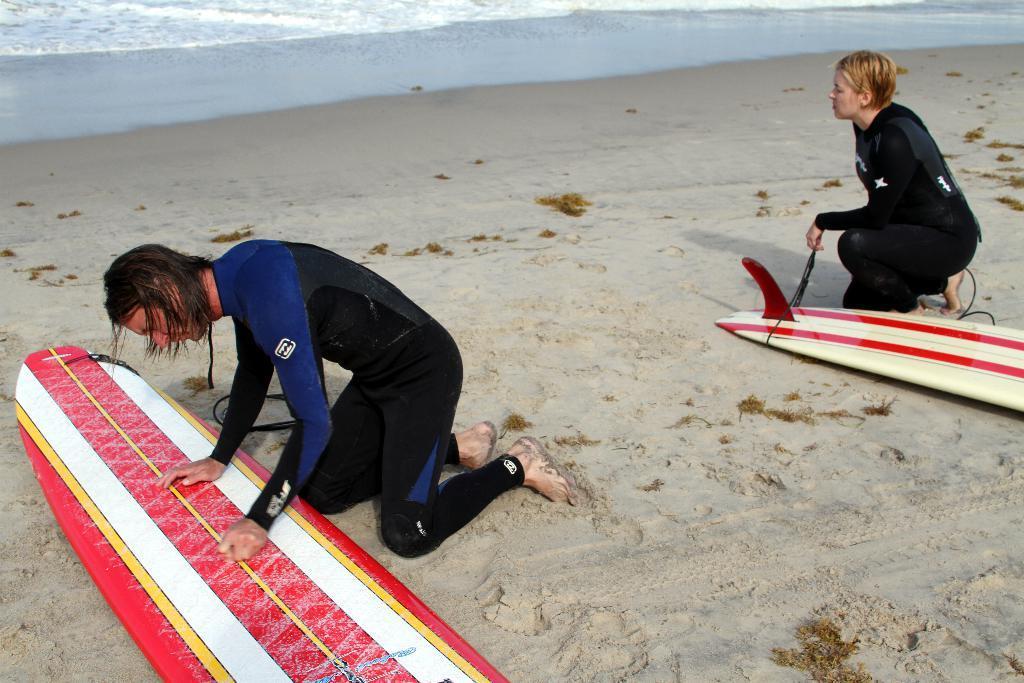Could you give a brief overview of what you see in this image? Here we can see two persons on the sand and there are surfboards. In the background we can see water. 